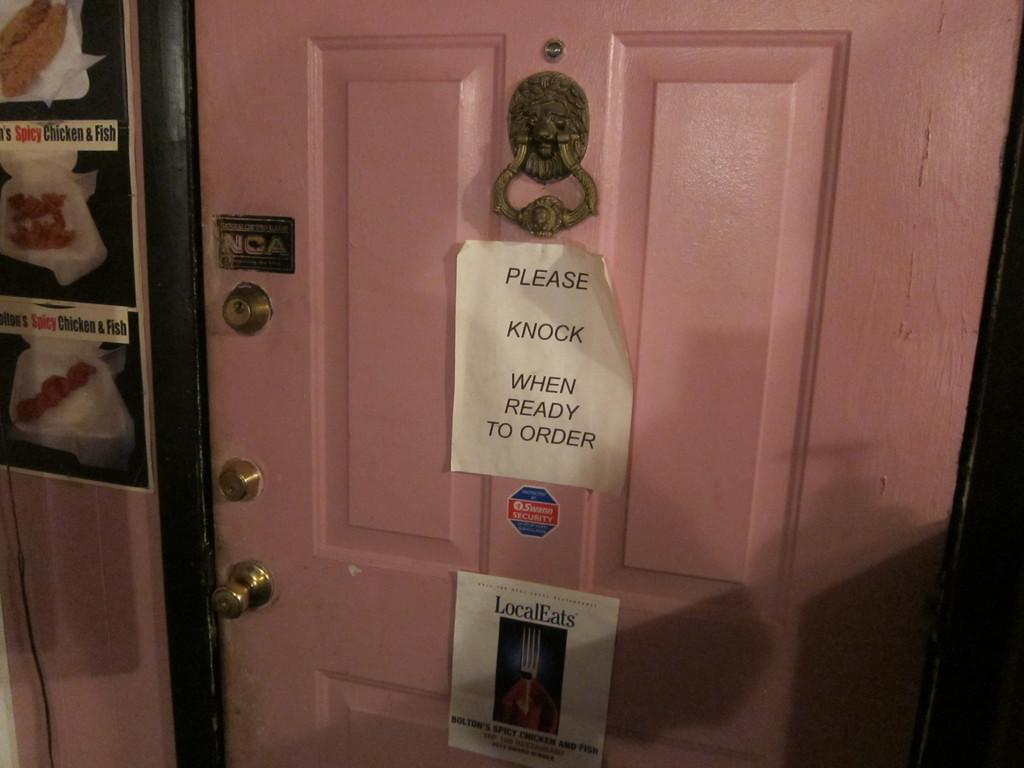<image>
Give a short and clear explanation of the subsequent image. A pink door entrance with a note on it saying Please Knock When Ready to Order 